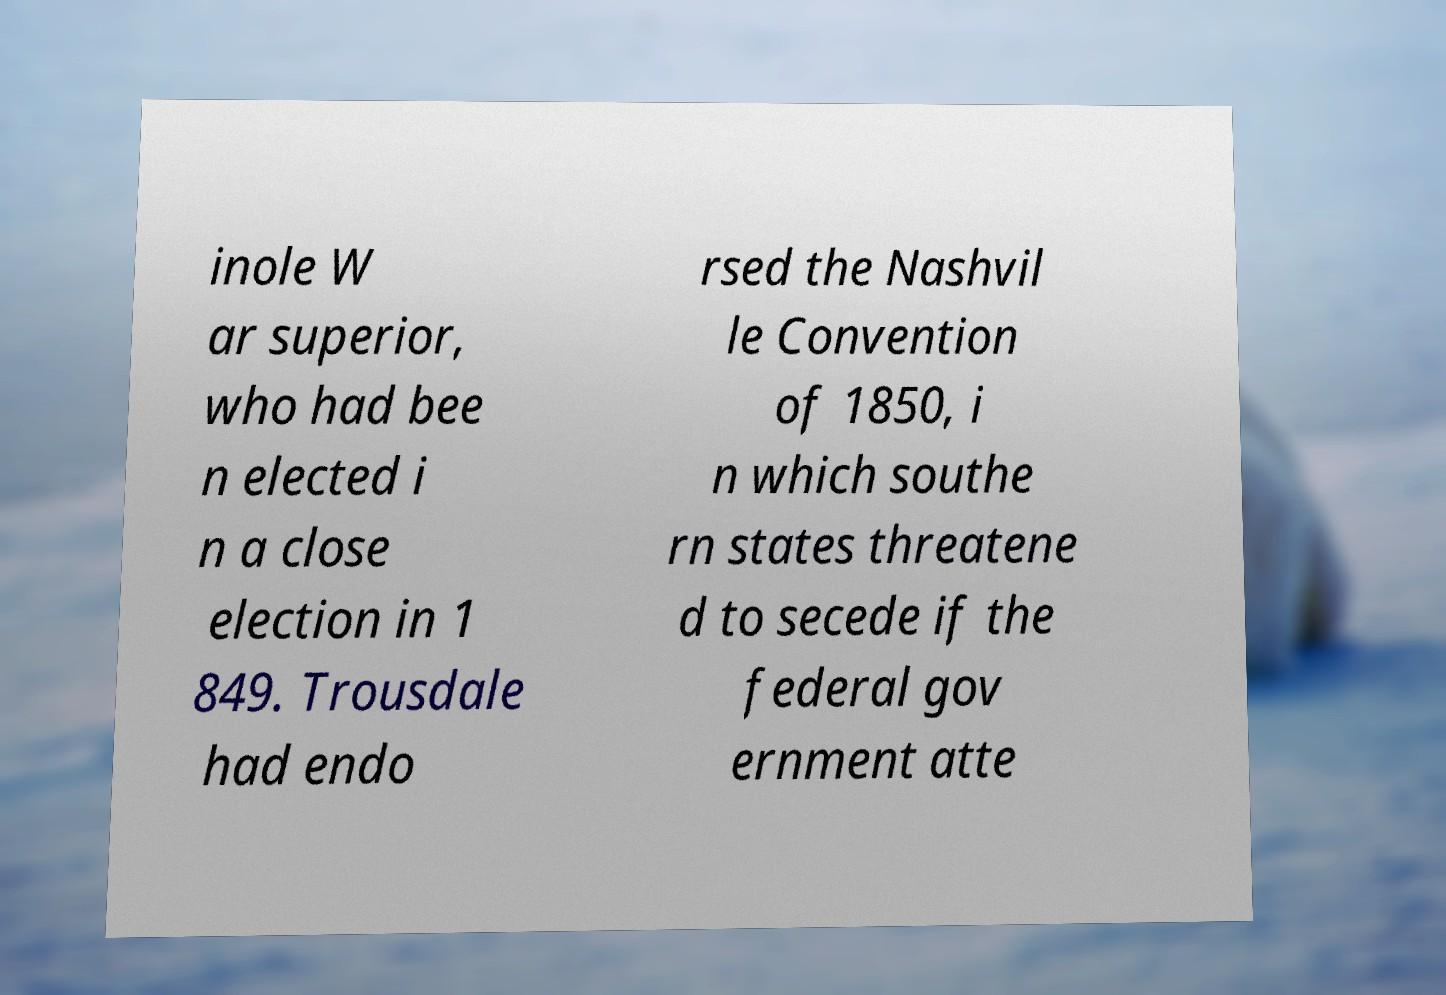Please read and relay the text visible in this image. What does it say? inole W ar superior, who had bee n elected i n a close election in 1 849. Trousdale had endo rsed the Nashvil le Convention of 1850, i n which southe rn states threatene d to secede if the federal gov ernment atte 